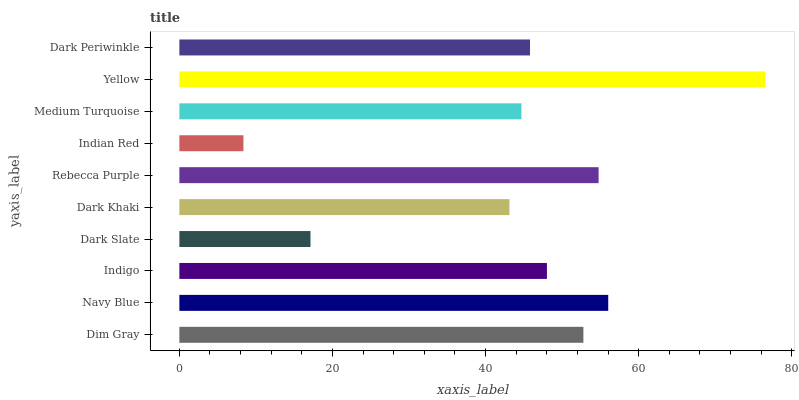Is Indian Red the minimum?
Answer yes or no. Yes. Is Yellow the maximum?
Answer yes or no. Yes. Is Navy Blue the minimum?
Answer yes or no. No. Is Navy Blue the maximum?
Answer yes or no. No. Is Navy Blue greater than Dim Gray?
Answer yes or no. Yes. Is Dim Gray less than Navy Blue?
Answer yes or no. Yes. Is Dim Gray greater than Navy Blue?
Answer yes or no. No. Is Navy Blue less than Dim Gray?
Answer yes or no. No. Is Indigo the high median?
Answer yes or no. Yes. Is Dark Periwinkle the low median?
Answer yes or no. Yes. Is Medium Turquoise the high median?
Answer yes or no. No. Is Rebecca Purple the low median?
Answer yes or no. No. 